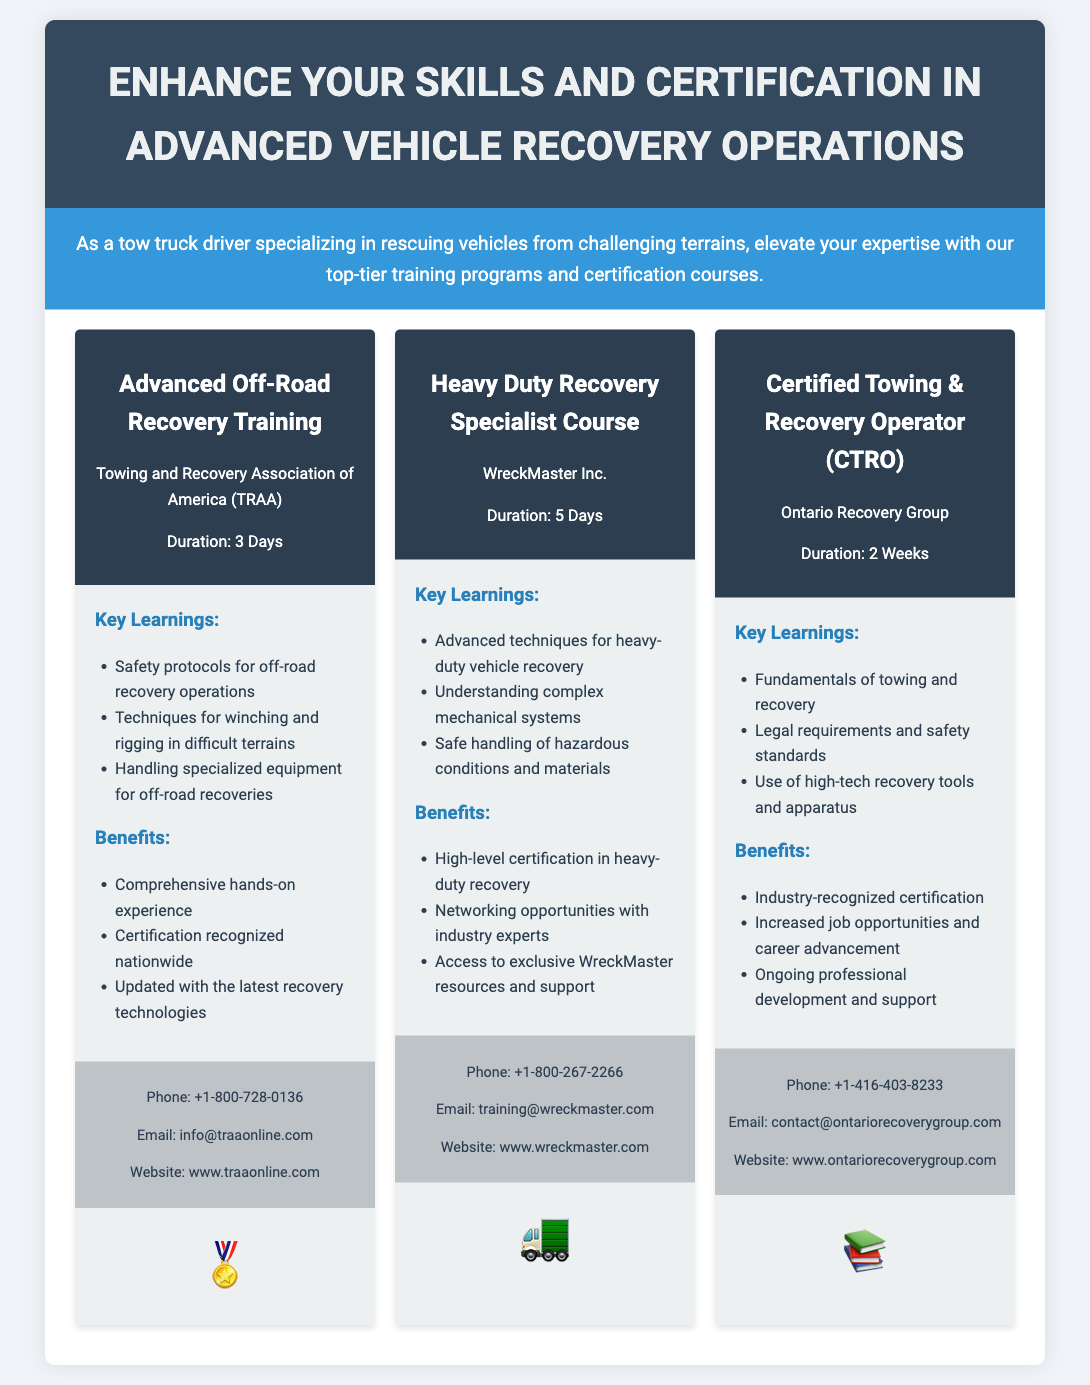What is the title of the flyer? The title of the flyer is prominently displayed in the header section.
Answer: Advanced Vehicle Recovery Training Programs How many days does the Advanced Off-Road Recovery Training last? The duration is mentioned under the program header for this course.
Answer: 3 Days Who offers the Heavy Duty Recovery Specialist Course? The name of the organization providing the course is included in the program header.
Answer: WreckMaster Inc What is one of the key learnings from the Certified Towing & Recovery Operator course? Key learnings are listed in the program content section for this course.
Answer: Fundamentals of towing and recovery What benefit is highlighted for the Advanced Off-Road Recovery Training? Benefits are detailed in the program content section.
Answer: Comprehensive hands-on experience How many hours of training are included for the Certified Towing & Recovery Operator certification? The duration is specified in the program header, converted from weeks to days for clarity.
Answer: 14 Days What icon is used for the Heavy Duty Recovery Specialist Course? The icon for each course is indicated in the program section.
Answer: 🚛 What is the contact phone number for the Ontario Recovery Group? Contact information is listed at the end of this program.
Answer: +1-416-403-8233 